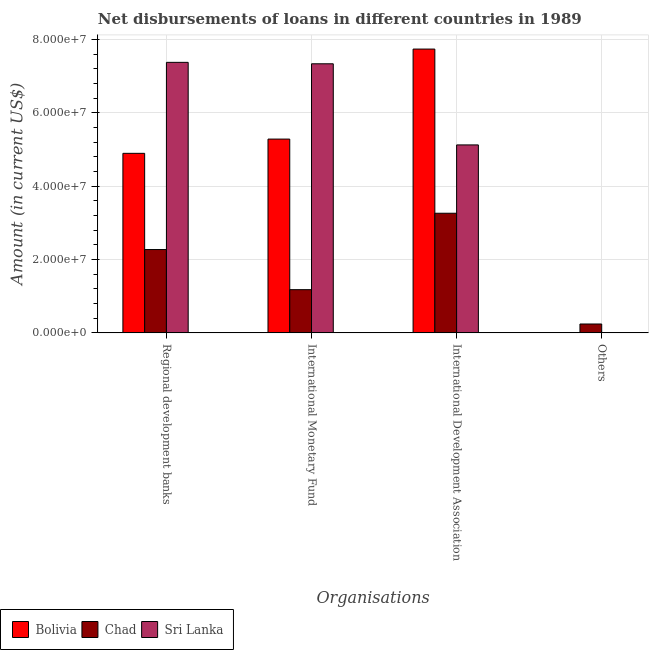How many different coloured bars are there?
Provide a short and direct response. 3. How many bars are there on the 4th tick from the left?
Your answer should be very brief. 1. What is the label of the 4th group of bars from the left?
Offer a terse response. Others. What is the amount of loan disimbursed by international development association in Sri Lanka?
Your answer should be compact. 5.12e+07. Across all countries, what is the maximum amount of loan disimbursed by international development association?
Your answer should be very brief. 7.74e+07. Across all countries, what is the minimum amount of loan disimbursed by regional development banks?
Offer a terse response. 2.27e+07. In which country was the amount of loan disimbursed by regional development banks maximum?
Your answer should be compact. Sri Lanka. What is the total amount of loan disimbursed by other organisations in the graph?
Offer a terse response. 2.42e+06. What is the difference between the amount of loan disimbursed by international monetary fund in Chad and that in Bolivia?
Your answer should be very brief. -4.11e+07. What is the difference between the amount of loan disimbursed by international monetary fund in Bolivia and the amount of loan disimbursed by other organisations in Sri Lanka?
Your answer should be compact. 5.28e+07. What is the average amount of loan disimbursed by international monetary fund per country?
Offer a terse response. 4.60e+07. What is the difference between the amount of loan disimbursed by international monetary fund and amount of loan disimbursed by regional development banks in Bolivia?
Offer a terse response. 3.88e+06. What is the ratio of the amount of loan disimbursed by international monetary fund in Chad to that in Bolivia?
Your answer should be compact. 0.22. Is the amount of loan disimbursed by regional development banks in Chad less than that in Bolivia?
Provide a short and direct response. Yes. What is the difference between the highest and the second highest amount of loan disimbursed by international development association?
Keep it short and to the point. 2.61e+07. What is the difference between the highest and the lowest amount of loan disimbursed by international monetary fund?
Give a very brief answer. 6.16e+07. In how many countries, is the amount of loan disimbursed by international development association greater than the average amount of loan disimbursed by international development association taken over all countries?
Provide a short and direct response. 1. Are all the bars in the graph horizontal?
Offer a very short reply. No. What is the difference between two consecutive major ticks on the Y-axis?
Keep it short and to the point. 2.00e+07. Are the values on the major ticks of Y-axis written in scientific E-notation?
Make the answer very short. Yes. Does the graph contain any zero values?
Offer a very short reply. Yes. Does the graph contain grids?
Make the answer very short. Yes. Where does the legend appear in the graph?
Your answer should be compact. Bottom left. How are the legend labels stacked?
Make the answer very short. Horizontal. What is the title of the graph?
Ensure brevity in your answer.  Net disbursements of loans in different countries in 1989. Does "Portugal" appear as one of the legend labels in the graph?
Provide a succinct answer. No. What is the label or title of the X-axis?
Your answer should be compact. Organisations. What is the Amount (in current US$) of Bolivia in Regional development banks?
Offer a very short reply. 4.90e+07. What is the Amount (in current US$) of Chad in Regional development banks?
Your answer should be very brief. 2.27e+07. What is the Amount (in current US$) of Sri Lanka in Regional development banks?
Offer a terse response. 7.38e+07. What is the Amount (in current US$) of Bolivia in International Monetary Fund?
Make the answer very short. 5.28e+07. What is the Amount (in current US$) in Chad in International Monetary Fund?
Your answer should be compact. 1.18e+07. What is the Amount (in current US$) in Sri Lanka in International Monetary Fund?
Keep it short and to the point. 7.34e+07. What is the Amount (in current US$) of Bolivia in International Development Association?
Your response must be concise. 7.74e+07. What is the Amount (in current US$) in Chad in International Development Association?
Your answer should be compact. 3.26e+07. What is the Amount (in current US$) in Sri Lanka in International Development Association?
Make the answer very short. 5.12e+07. What is the Amount (in current US$) of Chad in Others?
Give a very brief answer. 2.42e+06. Across all Organisations, what is the maximum Amount (in current US$) of Bolivia?
Offer a very short reply. 7.74e+07. Across all Organisations, what is the maximum Amount (in current US$) of Chad?
Offer a terse response. 3.26e+07. Across all Organisations, what is the maximum Amount (in current US$) in Sri Lanka?
Your answer should be compact. 7.38e+07. Across all Organisations, what is the minimum Amount (in current US$) in Chad?
Keep it short and to the point. 2.42e+06. What is the total Amount (in current US$) in Bolivia in the graph?
Provide a succinct answer. 1.79e+08. What is the total Amount (in current US$) of Chad in the graph?
Your answer should be very brief. 6.95e+07. What is the total Amount (in current US$) in Sri Lanka in the graph?
Your answer should be very brief. 1.98e+08. What is the difference between the Amount (in current US$) of Bolivia in Regional development banks and that in International Monetary Fund?
Your answer should be compact. -3.88e+06. What is the difference between the Amount (in current US$) in Chad in Regional development banks and that in International Monetary Fund?
Your response must be concise. 1.09e+07. What is the difference between the Amount (in current US$) of Sri Lanka in Regional development banks and that in International Monetary Fund?
Your response must be concise. 3.91e+05. What is the difference between the Amount (in current US$) in Bolivia in Regional development banks and that in International Development Association?
Provide a short and direct response. -2.84e+07. What is the difference between the Amount (in current US$) of Chad in Regional development banks and that in International Development Association?
Keep it short and to the point. -9.90e+06. What is the difference between the Amount (in current US$) of Sri Lanka in Regional development banks and that in International Development Association?
Your response must be concise. 2.25e+07. What is the difference between the Amount (in current US$) of Chad in Regional development banks and that in Others?
Provide a short and direct response. 2.03e+07. What is the difference between the Amount (in current US$) in Bolivia in International Monetary Fund and that in International Development Association?
Offer a terse response. -2.45e+07. What is the difference between the Amount (in current US$) of Chad in International Monetary Fund and that in International Development Association?
Provide a short and direct response. -2.08e+07. What is the difference between the Amount (in current US$) of Sri Lanka in International Monetary Fund and that in International Development Association?
Your answer should be very brief. 2.21e+07. What is the difference between the Amount (in current US$) of Chad in International Monetary Fund and that in Others?
Give a very brief answer. 9.36e+06. What is the difference between the Amount (in current US$) of Chad in International Development Association and that in Others?
Your response must be concise. 3.02e+07. What is the difference between the Amount (in current US$) in Bolivia in Regional development banks and the Amount (in current US$) in Chad in International Monetary Fund?
Offer a very short reply. 3.72e+07. What is the difference between the Amount (in current US$) of Bolivia in Regional development banks and the Amount (in current US$) of Sri Lanka in International Monetary Fund?
Your answer should be compact. -2.44e+07. What is the difference between the Amount (in current US$) of Chad in Regional development banks and the Amount (in current US$) of Sri Lanka in International Monetary Fund?
Offer a very short reply. -5.06e+07. What is the difference between the Amount (in current US$) of Bolivia in Regional development banks and the Amount (in current US$) of Chad in International Development Association?
Your answer should be very brief. 1.63e+07. What is the difference between the Amount (in current US$) of Bolivia in Regional development banks and the Amount (in current US$) of Sri Lanka in International Development Association?
Provide a short and direct response. -2.29e+06. What is the difference between the Amount (in current US$) in Chad in Regional development banks and the Amount (in current US$) in Sri Lanka in International Development Association?
Make the answer very short. -2.85e+07. What is the difference between the Amount (in current US$) in Bolivia in Regional development banks and the Amount (in current US$) in Chad in Others?
Offer a very short reply. 4.65e+07. What is the difference between the Amount (in current US$) in Bolivia in International Monetary Fund and the Amount (in current US$) in Chad in International Development Association?
Offer a very short reply. 2.02e+07. What is the difference between the Amount (in current US$) of Bolivia in International Monetary Fund and the Amount (in current US$) of Sri Lanka in International Development Association?
Offer a terse response. 1.59e+06. What is the difference between the Amount (in current US$) of Chad in International Monetary Fund and the Amount (in current US$) of Sri Lanka in International Development Association?
Your answer should be compact. -3.95e+07. What is the difference between the Amount (in current US$) in Bolivia in International Monetary Fund and the Amount (in current US$) in Chad in Others?
Give a very brief answer. 5.04e+07. What is the difference between the Amount (in current US$) of Bolivia in International Development Association and the Amount (in current US$) of Chad in Others?
Provide a short and direct response. 7.50e+07. What is the average Amount (in current US$) in Bolivia per Organisations?
Provide a succinct answer. 4.48e+07. What is the average Amount (in current US$) in Chad per Organisations?
Provide a succinct answer. 1.74e+07. What is the average Amount (in current US$) of Sri Lanka per Organisations?
Ensure brevity in your answer.  4.96e+07. What is the difference between the Amount (in current US$) of Bolivia and Amount (in current US$) of Chad in Regional development banks?
Your answer should be compact. 2.62e+07. What is the difference between the Amount (in current US$) in Bolivia and Amount (in current US$) in Sri Lanka in Regional development banks?
Your response must be concise. -2.48e+07. What is the difference between the Amount (in current US$) in Chad and Amount (in current US$) in Sri Lanka in Regional development banks?
Make the answer very short. -5.10e+07. What is the difference between the Amount (in current US$) of Bolivia and Amount (in current US$) of Chad in International Monetary Fund?
Give a very brief answer. 4.11e+07. What is the difference between the Amount (in current US$) in Bolivia and Amount (in current US$) in Sri Lanka in International Monetary Fund?
Make the answer very short. -2.05e+07. What is the difference between the Amount (in current US$) in Chad and Amount (in current US$) in Sri Lanka in International Monetary Fund?
Your response must be concise. -6.16e+07. What is the difference between the Amount (in current US$) of Bolivia and Amount (in current US$) of Chad in International Development Association?
Give a very brief answer. 4.48e+07. What is the difference between the Amount (in current US$) of Bolivia and Amount (in current US$) of Sri Lanka in International Development Association?
Your response must be concise. 2.61e+07. What is the difference between the Amount (in current US$) of Chad and Amount (in current US$) of Sri Lanka in International Development Association?
Your answer should be compact. -1.86e+07. What is the ratio of the Amount (in current US$) in Bolivia in Regional development banks to that in International Monetary Fund?
Provide a short and direct response. 0.93. What is the ratio of the Amount (in current US$) in Chad in Regional development banks to that in International Monetary Fund?
Your answer should be very brief. 1.93. What is the ratio of the Amount (in current US$) of Sri Lanka in Regional development banks to that in International Monetary Fund?
Your response must be concise. 1.01. What is the ratio of the Amount (in current US$) in Bolivia in Regional development banks to that in International Development Association?
Offer a terse response. 0.63. What is the ratio of the Amount (in current US$) in Chad in Regional development banks to that in International Development Association?
Keep it short and to the point. 0.7. What is the ratio of the Amount (in current US$) in Sri Lanka in Regional development banks to that in International Development Association?
Your answer should be very brief. 1.44. What is the ratio of the Amount (in current US$) in Chad in Regional development banks to that in Others?
Your response must be concise. 9.39. What is the ratio of the Amount (in current US$) in Bolivia in International Monetary Fund to that in International Development Association?
Your response must be concise. 0.68. What is the ratio of the Amount (in current US$) in Chad in International Monetary Fund to that in International Development Association?
Your answer should be very brief. 0.36. What is the ratio of the Amount (in current US$) of Sri Lanka in International Monetary Fund to that in International Development Association?
Ensure brevity in your answer.  1.43. What is the ratio of the Amount (in current US$) in Chad in International Monetary Fund to that in Others?
Provide a succinct answer. 4.87. What is the ratio of the Amount (in current US$) in Chad in International Development Association to that in Others?
Your response must be concise. 13.48. What is the difference between the highest and the second highest Amount (in current US$) in Bolivia?
Offer a terse response. 2.45e+07. What is the difference between the highest and the second highest Amount (in current US$) of Chad?
Offer a terse response. 9.90e+06. What is the difference between the highest and the second highest Amount (in current US$) of Sri Lanka?
Your answer should be very brief. 3.91e+05. What is the difference between the highest and the lowest Amount (in current US$) in Bolivia?
Your response must be concise. 7.74e+07. What is the difference between the highest and the lowest Amount (in current US$) in Chad?
Provide a short and direct response. 3.02e+07. What is the difference between the highest and the lowest Amount (in current US$) in Sri Lanka?
Make the answer very short. 7.38e+07. 